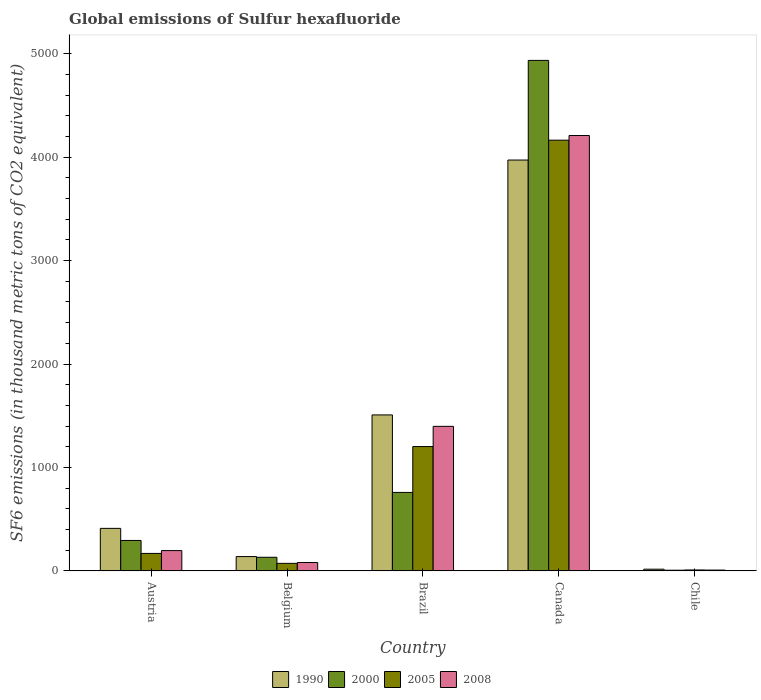How many different coloured bars are there?
Your answer should be very brief. 4. Are the number of bars per tick equal to the number of legend labels?
Offer a terse response. Yes. How many bars are there on the 5th tick from the left?
Ensure brevity in your answer.  4. How many bars are there on the 4th tick from the right?
Offer a very short reply. 4. What is the global emissions of Sulfur hexafluoride in 2008 in Canada?
Provide a short and direct response. 4208.8. Across all countries, what is the maximum global emissions of Sulfur hexafluoride in 2005?
Provide a short and direct response. 4163.8. Across all countries, what is the minimum global emissions of Sulfur hexafluoride in 2008?
Ensure brevity in your answer.  7.9. In which country was the global emissions of Sulfur hexafluoride in 2008 maximum?
Ensure brevity in your answer.  Canada. What is the total global emissions of Sulfur hexafluoride in 2005 in the graph?
Your answer should be compact. 5616.7. What is the difference between the global emissions of Sulfur hexafluoride in 2005 in Austria and that in Chile?
Keep it short and to the point. 160. What is the difference between the global emissions of Sulfur hexafluoride in 2000 in Austria and the global emissions of Sulfur hexafluoride in 1990 in Belgium?
Make the answer very short. 155.9. What is the average global emissions of Sulfur hexafluoride in 2000 per country?
Offer a terse response. 1225.32. What is the difference between the global emissions of Sulfur hexafluoride of/in 2008 and global emissions of Sulfur hexafluoride of/in 1990 in Austria?
Keep it short and to the point. -214.8. In how many countries, is the global emissions of Sulfur hexafluoride in 2008 greater than 2000 thousand metric tons?
Provide a short and direct response. 1. What is the ratio of the global emissions of Sulfur hexafluoride in 2005 in Brazil to that in Chile?
Give a very brief answer. 133.56. What is the difference between the highest and the second highest global emissions of Sulfur hexafluoride in 2008?
Provide a short and direct response. 4012.4. What is the difference between the highest and the lowest global emissions of Sulfur hexafluoride in 1990?
Offer a very short reply. 3955.3. Are all the bars in the graph horizontal?
Keep it short and to the point. No. What is the difference between two consecutive major ticks on the Y-axis?
Ensure brevity in your answer.  1000. Does the graph contain any zero values?
Your response must be concise. No. How are the legend labels stacked?
Your answer should be compact. Horizontal. What is the title of the graph?
Provide a succinct answer. Global emissions of Sulfur hexafluoride. What is the label or title of the X-axis?
Offer a very short reply. Country. What is the label or title of the Y-axis?
Make the answer very short. SF6 emissions (in thousand metric tons of CO2 equivalent). What is the SF6 emissions (in thousand metric tons of CO2 equivalent) in 1990 in Austria?
Provide a succinct answer. 411.2. What is the SF6 emissions (in thousand metric tons of CO2 equivalent) in 2000 in Austria?
Offer a terse response. 294.4. What is the SF6 emissions (in thousand metric tons of CO2 equivalent) of 2005 in Austria?
Ensure brevity in your answer.  169. What is the SF6 emissions (in thousand metric tons of CO2 equivalent) in 2008 in Austria?
Make the answer very short. 196.4. What is the SF6 emissions (in thousand metric tons of CO2 equivalent) in 1990 in Belgium?
Provide a succinct answer. 138.5. What is the SF6 emissions (in thousand metric tons of CO2 equivalent) of 2000 in Belgium?
Ensure brevity in your answer.  131.7. What is the SF6 emissions (in thousand metric tons of CO2 equivalent) of 2005 in Belgium?
Ensure brevity in your answer.  72.9. What is the SF6 emissions (in thousand metric tons of CO2 equivalent) of 2008 in Belgium?
Keep it short and to the point. 80.9. What is the SF6 emissions (in thousand metric tons of CO2 equivalent) of 1990 in Brazil?
Make the answer very short. 1507.9. What is the SF6 emissions (in thousand metric tons of CO2 equivalent) of 2000 in Brazil?
Give a very brief answer. 758.7. What is the SF6 emissions (in thousand metric tons of CO2 equivalent) of 2005 in Brazil?
Keep it short and to the point. 1202. What is the SF6 emissions (in thousand metric tons of CO2 equivalent) in 2008 in Brazil?
Your answer should be very brief. 1397.3. What is the SF6 emissions (in thousand metric tons of CO2 equivalent) of 1990 in Canada?
Provide a short and direct response. 3971.8. What is the SF6 emissions (in thousand metric tons of CO2 equivalent) in 2000 in Canada?
Give a very brief answer. 4935.1. What is the SF6 emissions (in thousand metric tons of CO2 equivalent) in 2005 in Canada?
Your response must be concise. 4163.8. What is the SF6 emissions (in thousand metric tons of CO2 equivalent) of 2008 in Canada?
Give a very brief answer. 4208.8. What is the SF6 emissions (in thousand metric tons of CO2 equivalent) of 1990 in Chile?
Provide a short and direct response. 16.5. Across all countries, what is the maximum SF6 emissions (in thousand metric tons of CO2 equivalent) in 1990?
Your answer should be very brief. 3971.8. Across all countries, what is the maximum SF6 emissions (in thousand metric tons of CO2 equivalent) of 2000?
Offer a terse response. 4935.1. Across all countries, what is the maximum SF6 emissions (in thousand metric tons of CO2 equivalent) in 2005?
Provide a short and direct response. 4163.8. Across all countries, what is the maximum SF6 emissions (in thousand metric tons of CO2 equivalent) in 2008?
Provide a short and direct response. 4208.8. Across all countries, what is the minimum SF6 emissions (in thousand metric tons of CO2 equivalent) of 2005?
Keep it short and to the point. 9. What is the total SF6 emissions (in thousand metric tons of CO2 equivalent) of 1990 in the graph?
Offer a terse response. 6045.9. What is the total SF6 emissions (in thousand metric tons of CO2 equivalent) in 2000 in the graph?
Offer a terse response. 6126.6. What is the total SF6 emissions (in thousand metric tons of CO2 equivalent) in 2005 in the graph?
Offer a very short reply. 5616.7. What is the total SF6 emissions (in thousand metric tons of CO2 equivalent) of 2008 in the graph?
Your response must be concise. 5891.3. What is the difference between the SF6 emissions (in thousand metric tons of CO2 equivalent) of 1990 in Austria and that in Belgium?
Provide a succinct answer. 272.7. What is the difference between the SF6 emissions (in thousand metric tons of CO2 equivalent) in 2000 in Austria and that in Belgium?
Provide a short and direct response. 162.7. What is the difference between the SF6 emissions (in thousand metric tons of CO2 equivalent) of 2005 in Austria and that in Belgium?
Your answer should be compact. 96.1. What is the difference between the SF6 emissions (in thousand metric tons of CO2 equivalent) in 2008 in Austria and that in Belgium?
Ensure brevity in your answer.  115.5. What is the difference between the SF6 emissions (in thousand metric tons of CO2 equivalent) of 1990 in Austria and that in Brazil?
Keep it short and to the point. -1096.7. What is the difference between the SF6 emissions (in thousand metric tons of CO2 equivalent) in 2000 in Austria and that in Brazil?
Offer a terse response. -464.3. What is the difference between the SF6 emissions (in thousand metric tons of CO2 equivalent) of 2005 in Austria and that in Brazil?
Make the answer very short. -1033. What is the difference between the SF6 emissions (in thousand metric tons of CO2 equivalent) in 2008 in Austria and that in Brazil?
Keep it short and to the point. -1200.9. What is the difference between the SF6 emissions (in thousand metric tons of CO2 equivalent) of 1990 in Austria and that in Canada?
Your answer should be compact. -3560.6. What is the difference between the SF6 emissions (in thousand metric tons of CO2 equivalent) in 2000 in Austria and that in Canada?
Your answer should be compact. -4640.7. What is the difference between the SF6 emissions (in thousand metric tons of CO2 equivalent) in 2005 in Austria and that in Canada?
Offer a terse response. -3994.8. What is the difference between the SF6 emissions (in thousand metric tons of CO2 equivalent) in 2008 in Austria and that in Canada?
Your answer should be compact. -4012.4. What is the difference between the SF6 emissions (in thousand metric tons of CO2 equivalent) of 1990 in Austria and that in Chile?
Give a very brief answer. 394.7. What is the difference between the SF6 emissions (in thousand metric tons of CO2 equivalent) in 2000 in Austria and that in Chile?
Make the answer very short. 287.7. What is the difference between the SF6 emissions (in thousand metric tons of CO2 equivalent) in 2005 in Austria and that in Chile?
Your answer should be very brief. 160. What is the difference between the SF6 emissions (in thousand metric tons of CO2 equivalent) in 2008 in Austria and that in Chile?
Your answer should be compact. 188.5. What is the difference between the SF6 emissions (in thousand metric tons of CO2 equivalent) in 1990 in Belgium and that in Brazil?
Your response must be concise. -1369.4. What is the difference between the SF6 emissions (in thousand metric tons of CO2 equivalent) of 2000 in Belgium and that in Brazil?
Keep it short and to the point. -627. What is the difference between the SF6 emissions (in thousand metric tons of CO2 equivalent) in 2005 in Belgium and that in Brazil?
Offer a very short reply. -1129.1. What is the difference between the SF6 emissions (in thousand metric tons of CO2 equivalent) of 2008 in Belgium and that in Brazil?
Provide a succinct answer. -1316.4. What is the difference between the SF6 emissions (in thousand metric tons of CO2 equivalent) of 1990 in Belgium and that in Canada?
Your answer should be compact. -3833.3. What is the difference between the SF6 emissions (in thousand metric tons of CO2 equivalent) of 2000 in Belgium and that in Canada?
Keep it short and to the point. -4803.4. What is the difference between the SF6 emissions (in thousand metric tons of CO2 equivalent) of 2005 in Belgium and that in Canada?
Provide a short and direct response. -4090.9. What is the difference between the SF6 emissions (in thousand metric tons of CO2 equivalent) in 2008 in Belgium and that in Canada?
Give a very brief answer. -4127.9. What is the difference between the SF6 emissions (in thousand metric tons of CO2 equivalent) of 1990 in Belgium and that in Chile?
Your response must be concise. 122. What is the difference between the SF6 emissions (in thousand metric tons of CO2 equivalent) in 2000 in Belgium and that in Chile?
Your response must be concise. 125. What is the difference between the SF6 emissions (in thousand metric tons of CO2 equivalent) in 2005 in Belgium and that in Chile?
Provide a short and direct response. 63.9. What is the difference between the SF6 emissions (in thousand metric tons of CO2 equivalent) in 2008 in Belgium and that in Chile?
Provide a succinct answer. 73. What is the difference between the SF6 emissions (in thousand metric tons of CO2 equivalent) of 1990 in Brazil and that in Canada?
Provide a succinct answer. -2463.9. What is the difference between the SF6 emissions (in thousand metric tons of CO2 equivalent) in 2000 in Brazil and that in Canada?
Offer a very short reply. -4176.4. What is the difference between the SF6 emissions (in thousand metric tons of CO2 equivalent) in 2005 in Brazil and that in Canada?
Provide a succinct answer. -2961.8. What is the difference between the SF6 emissions (in thousand metric tons of CO2 equivalent) in 2008 in Brazil and that in Canada?
Keep it short and to the point. -2811.5. What is the difference between the SF6 emissions (in thousand metric tons of CO2 equivalent) of 1990 in Brazil and that in Chile?
Your response must be concise. 1491.4. What is the difference between the SF6 emissions (in thousand metric tons of CO2 equivalent) of 2000 in Brazil and that in Chile?
Keep it short and to the point. 752. What is the difference between the SF6 emissions (in thousand metric tons of CO2 equivalent) of 2005 in Brazil and that in Chile?
Your response must be concise. 1193. What is the difference between the SF6 emissions (in thousand metric tons of CO2 equivalent) in 2008 in Brazil and that in Chile?
Provide a succinct answer. 1389.4. What is the difference between the SF6 emissions (in thousand metric tons of CO2 equivalent) of 1990 in Canada and that in Chile?
Keep it short and to the point. 3955.3. What is the difference between the SF6 emissions (in thousand metric tons of CO2 equivalent) of 2000 in Canada and that in Chile?
Your response must be concise. 4928.4. What is the difference between the SF6 emissions (in thousand metric tons of CO2 equivalent) in 2005 in Canada and that in Chile?
Give a very brief answer. 4154.8. What is the difference between the SF6 emissions (in thousand metric tons of CO2 equivalent) in 2008 in Canada and that in Chile?
Your answer should be very brief. 4200.9. What is the difference between the SF6 emissions (in thousand metric tons of CO2 equivalent) of 1990 in Austria and the SF6 emissions (in thousand metric tons of CO2 equivalent) of 2000 in Belgium?
Offer a terse response. 279.5. What is the difference between the SF6 emissions (in thousand metric tons of CO2 equivalent) of 1990 in Austria and the SF6 emissions (in thousand metric tons of CO2 equivalent) of 2005 in Belgium?
Offer a very short reply. 338.3. What is the difference between the SF6 emissions (in thousand metric tons of CO2 equivalent) of 1990 in Austria and the SF6 emissions (in thousand metric tons of CO2 equivalent) of 2008 in Belgium?
Offer a terse response. 330.3. What is the difference between the SF6 emissions (in thousand metric tons of CO2 equivalent) in 2000 in Austria and the SF6 emissions (in thousand metric tons of CO2 equivalent) in 2005 in Belgium?
Your answer should be compact. 221.5. What is the difference between the SF6 emissions (in thousand metric tons of CO2 equivalent) in 2000 in Austria and the SF6 emissions (in thousand metric tons of CO2 equivalent) in 2008 in Belgium?
Give a very brief answer. 213.5. What is the difference between the SF6 emissions (in thousand metric tons of CO2 equivalent) of 2005 in Austria and the SF6 emissions (in thousand metric tons of CO2 equivalent) of 2008 in Belgium?
Provide a short and direct response. 88.1. What is the difference between the SF6 emissions (in thousand metric tons of CO2 equivalent) in 1990 in Austria and the SF6 emissions (in thousand metric tons of CO2 equivalent) in 2000 in Brazil?
Provide a succinct answer. -347.5. What is the difference between the SF6 emissions (in thousand metric tons of CO2 equivalent) of 1990 in Austria and the SF6 emissions (in thousand metric tons of CO2 equivalent) of 2005 in Brazil?
Your answer should be very brief. -790.8. What is the difference between the SF6 emissions (in thousand metric tons of CO2 equivalent) of 1990 in Austria and the SF6 emissions (in thousand metric tons of CO2 equivalent) of 2008 in Brazil?
Ensure brevity in your answer.  -986.1. What is the difference between the SF6 emissions (in thousand metric tons of CO2 equivalent) of 2000 in Austria and the SF6 emissions (in thousand metric tons of CO2 equivalent) of 2005 in Brazil?
Provide a short and direct response. -907.6. What is the difference between the SF6 emissions (in thousand metric tons of CO2 equivalent) of 2000 in Austria and the SF6 emissions (in thousand metric tons of CO2 equivalent) of 2008 in Brazil?
Keep it short and to the point. -1102.9. What is the difference between the SF6 emissions (in thousand metric tons of CO2 equivalent) in 2005 in Austria and the SF6 emissions (in thousand metric tons of CO2 equivalent) in 2008 in Brazil?
Your response must be concise. -1228.3. What is the difference between the SF6 emissions (in thousand metric tons of CO2 equivalent) in 1990 in Austria and the SF6 emissions (in thousand metric tons of CO2 equivalent) in 2000 in Canada?
Your answer should be compact. -4523.9. What is the difference between the SF6 emissions (in thousand metric tons of CO2 equivalent) of 1990 in Austria and the SF6 emissions (in thousand metric tons of CO2 equivalent) of 2005 in Canada?
Ensure brevity in your answer.  -3752.6. What is the difference between the SF6 emissions (in thousand metric tons of CO2 equivalent) in 1990 in Austria and the SF6 emissions (in thousand metric tons of CO2 equivalent) in 2008 in Canada?
Your answer should be very brief. -3797.6. What is the difference between the SF6 emissions (in thousand metric tons of CO2 equivalent) in 2000 in Austria and the SF6 emissions (in thousand metric tons of CO2 equivalent) in 2005 in Canada?
Your answer should be very brief. -3869.4. What is the difference between the SF6 emissions (in thousand metric tons of CO2 equivalent) in 2000 in Austria and the SF6 emissions (in thousand metric tons of CO2 equivalent) in 2008 in Canada?
Provide a succinct answer. -3914.4. What is the difference between the SF6 emissions (in thousand metric tons of CO2 equivalent) of 2005 in Austria and the SF6 emissions (in thousand metric tons of CO2 equivalent) of 2008 in Canada?
Your response must be concise. -4039.8. What is the difference between the SF6 emissions (in thousand metric tons of CO2 equivalent) of 1990 in Austria and the SF6 emissions (in thousand metric tons of CO2 equivalent) of 2000 in Chile?
Your answer should be compact. 404.5. What is the difference between the SF6 emissions (in thousand metric tons of CO2 equivalent) in 1990 in Austria and the SF6 emissions (in thousand metric tons of CO2 equivalent) in 2005 in Chile?
Keep it short and to the point. 402.2. What is the difference between the SF6 emissions (in thousand metric tons of CO2 equivalent) of 1990 in Austria and the SF6 emissions (in thousand metric tons of CO2 equivalent) of 2008 in Chile?
Ensure brevity in your answer.  403.3. What is the difference between the SF6 emissions (in thousand metric tons of CO2 equivalent) of 2000 in Austria and the SF6 emissions (in thousand metric tons of CO2 equivalent) of 2005 in Chile?
Make the answer very short. 285.4. What is the difference between the SF6 emissions (in thousand metric tons of CO2 equivalent) in 2000 in Austria and the SF6 emissions (in thousand metric tons of CO2 equivalent) in 2008 in Chile?
Give a very brief answer. 286.5. What is the difference between the SF6 emissions (in thousand metric tons of CO2 equivalent) of 2005 in Austria and the SF6 emissions (in thousand metric tons of CO2 equivalent) of 2008 in Chile?
Ensure brevity in your answer.  161.1. What is the difference between the SF6 emissions (in thousand metric tons of CO2 equivalent) of 1990 in Belgium and the SF6 emissions (in thousand metric tons of CO2 equivalent) of 2000 in Brazil?
Make the answer very short. -620.2. What is the difference between the SF6 emissions (in thousand metric tons of CO2 equivalent) of 1990 in Belgium and the SF6 emissions (in thousand metric tons of CO2 equivalent) of 2005 in Brazil?
Offer a terse response. -1063.5. What is the difference between the SF6 emissions (in thousand metric tons of CO2 equivalent) of 1990 in Belgium and the SF6 emissions (in thousand metric tons of CO2 equivalent) of 2008 in Brazil?
Ensure brevity in your answer.  -1258.8. What is the difference between the SF6 emissions (in thousand metric tons of CO2 equivalent) of 2000 in Belgium and the SF6 emissions (in thousand metric tons of CO2 equivalent) of 2005 in Brazil?
Your answer should be compact. -1070.3. What is the difference between the SF6 emissions (in thousand metric tons of CO2 equivalent) of 2000 in Belgium and the SF6 emissions (in thousand metric tons of CO2 equivalent) of 2008 in Brazil?
Provide a short and direct response. -1265.6. What is the difference between the SF6 emissions (in thousand metric tons of CO2 equivalent) in 2005 in Belgium and the SF6 emissions (in thousand metric tons of CO2 equivalent) in 2008 in Brazil?
Give a very brief answer. -1324.4. What is the difference between the SF6 emissions (in thousand metric tons of CO2 equivalent) in 1990 in Belgium and the SF6 emissions (in thousand metric tons of CO2 equivalent) in 2000 in Canada?
Keep it short and to the point. -4796.6. What is the difference between the SF6 emissions (in thousand metric tons of CO2 equivalent) of 1990 in Belgium and the SF6 emissions (in thousand metric tons of CO2 equivalent) of 2005 in Canada?
Offer a very short reply. -4025.3. What is the difference between the SF6 emissions (in thousand metric tons of CO2 equivalent) in 1990 in Belgium and the SF6 emissions (in thousand metric tons of CO2 equivalent) in 2008 in Canada?
Ensure brevity in your answer.  -4070.3. What is the difference between the SF6 emissions (in thousand metric tons of CO2 equivalent) of 2000 in Belgium and the SF6 emissions (in thousand metric tons of CO2 equivalent) of 2005 in Canada?
Your answer should be compact. -4032.1. What is the difference between the SF6 emissions (in thousand metric tons of CO2 equivalent) in 2000 in Belgium and the SF6 emissions (in thousand metric tons of CO2 equivalent) in 2008 in Canada?
Your answer should be very brief. -4077.1. What is the difference between the SF6 emissions (in thousand metric tons of CO2 equivalent) in 2005 in Belgium and the SF6 emissions (in thousand metric tons of CO2 equivalent) in 2008 in Canada?
Offer a terse response. -4135.9. What is the difference between the SF6 emissions (in thousand metric tons of CO2 equivalent) of 1990 in Belgium and the SF6 emissions (in thousand metric tons of CO2 equivalent) of 2000 in Chile?
Give a very brief answer. 131.8. What is the difference between the SF6 emissions (in thousand metric tons of CO2 equivalent) in 1990 in Belgium and the SF6 emissions (in thousand metric tons of CO2 equivalent) in 2005 in Chile?
Keep it short and to the point. 129.5. What is the difference between the SF6 emissions (in thousand metric tons of CO2 equivalent) of 1990 in Belgium and the SF6 emissions (in thousand metric tons of CO2 equivalent) of 2008 in Chile?
Offer a terse response. 130.6. What is the difference between the SF6 emissions (in thousand metric tons of CO2 equivalent) of 2000 in Belgium and the SF6 emissions (in thousand metric tons of CO2 equivalent) of 2005 in Chile?
Provide a short and direct response. 122.7. What is the difference between the SF6 emissions (in thousand metric tons of CO2 equivalent) of 2000 in Belgium and the SF6 emissions (in thousand metric tons of CO2 equivalent) of 2008 in Chile?
Provide a short and direct response. 123.8. What is the difference between the SF6 emissions (in thousand metric tons of CO2 equivalent) of 2005 in Belgium and the SF6 emissions (in thousand metric tons of CO2 equivalent) of 2008 in Chile?
Make the answer very short. 65. What is the difference between the SF6 emissions (in thousand metric tons of CO2 equivalent) of 1990 in Brazil and the SF6 emissions (in thousand metric tons of CO2 equivalent) of 2000 in Canada?
Make the answer very short. -3427.2. What is the difference between the SF6 emissions (in thousand metric tons of CO2 equivalent) of 1990 in Brazil and the SF6 emissions (in thousand metric tons of CO2 equivalent) of 2005 in Canada?
Offer a very short reply. -2655.9. What is the difference between the SF6 emissions (in thousand metric tons of CO2 equivalent) of 1990 in Brazil and the SF6 emissions (in thousand metric tons of CO2 equivalent) of 2008 in Canada?
Provide a short and direct response. -2700.9. What is the difference between the SF6 emissions (in thousand metric tons of CO2 equivalent) of 2000 in Brazil and the SF6 emissions (in thousand metric tons of CO2 equivalent) of 2005 in Canada?
Provide a short and direct response. -3405.1. What is the difference between the SF6 emissions (in thousand metric tons of CO2 equivalent) of 2000 in Brazil and the SF6 emissions (in thousand metric tons of CO2 equivalent) of 2008 in Canada?
Keep it short and to the point. -3450.1. What is the difference between the SF6 emissions (in thousand metric tons of CO2 equivalent) in 2005 in Brazil and the SF6 emissions (in thousand metric tons of CO2 equivalent) in 2008 in Canada?
Provide a short and direct response. -3006.8. What is the difference between the SF6 emissions (in thousand metric tons of CO2 equivalent) of 1990 in Brazil and the SF6 emissions (in thousand metric tons of CO2 equivalent) of 2000 in Chile?
Provide a short and direct response. 1501.2. What is the difference between the SF6 emissions (in thousand metric tons of CO2 equivalent) of 1990 in Brazil and the SF6 emissions (in thousand metric tons of CO2 equivalent) of 2005 in Chile?
Make the answer very short. 1498.9. What is the difference between the SF6 emissions (in thousand metric tons of CO2 equivalent) in 1990 in Brazil and the SF6 emissions (in thousand metric tons of CO2 equivalent) in 2008 in Chile?
Your answer should be compact. 1500. What is the difference between the SF6 emissions (in thousand metric tons of CO2 equivalent) of 2000 in Brazil and the SF6 emissions (in thousand metric tons of CO2 equivalent) of 2005 in Chile?
Make the answer very short. 749.7. What is the difference between the SF6 emissions (in thousand metric tons of CO2 equivalent) in 2000 in Brazil and the SF6 emissions (in thousand metric tons of CO2 equivalent) in 2008 in Chile?
Keep it short and to the point. 750.8. What is the difference between the SF6 emissions (in thousand metric tons of CO2 equivalent) of 2005 in Brazil and the SF6 emissions (in thousand metric tons of CO2 equivalent) of 2008 in Chile?
Your response must be concise. 1194.1. What is the difference between the SF6 emissions (in thousand metric tons of CO2 equivalent) of 1990 in Canada and the SF6 emissions (in thousand metric tons of CO2 equivalent) of 2000 in Chile?
Your answer should be very brief. 3965.1. What is the difference between the SF6 emissions (in thousand metric tons of CO2 equivalent) in 1990 in Canada and the SF6 emissions (in thousand metric tons of CO2 equivalent) in 2005 in Chile?
Make the answer very short. 3962.8. What is the difference between the SF6 emissions (in thousand metric tons of CO2 equivalent) in 1990 in Canada and the SF6 emissions (in thousand metric tons of CO2 equivalent) in 2008 in Chile?
Your answer should be very brief. 3963.9. What is the difference between the SF6 emissions (in thousand metric tons of CO2 equivalent) in 2000 in Canada and the SF6 emissions (in thousand metric tons of CO2 equivalent) in 2005 in Chile?
Provide a short and direct response. 4926.1. What is the difference between the SF6 emissions (in thousand metric tons of CO2 equivalent) of 2000 in Canada and the SF6 emissions (in thousand metric tons of CO2 equivalent) of 2008 in Chile?
Provide a short and direct response. 4927.2. What is the difference between the SF6 emissions (in thousand metric tons of CO2 equivalent) in 2005 in Canada and the SF6 emissions (in thousand metric tons of CO2 equivalent) in 2008 in Chile?
Your response must be concise. 4155.9. What is the average SF6 emissions (in thousand metric tons of CO2 equivalent) in 1990 per country?
Give a very brief answer. 1209.18. What is the average SF6 emissions (in thousand metric tons of CO2 equivalent) in 2000 per country?
Offer a very short reply. 1225.32. What is the average SF6 emissions (in thousand metric tons of CO2 equivalent) in 2005 per country?
Offer a terse response. 1123.34. What is the average SF6 emissions (in thousand metric tons of CO2 equivalent) of 2008 per country?
Keep it short and to the point. 1178.26. What is the difference between the SF6 emissions (in thousand metric tons of CO2 equivalent) in 1990 and SF6 emissions (in thousand metric tons of CO2 equivalent) in 2000 in Austria?
Keep it short and to the point. 116.8. What is the difference between the SF6 emissions (in thousand metric tons of CO2 equivalent) in 1990 and SF6 emissions (in thousand metric tons of CO2 equivalent) in 2005 in Austria?
Your answer should be very brief. 242.2. What is the difference between the SF6 emissions (in thousand metric tons of CO2 equivalent) of 1990 and SF6 emissions (in thousand metric tons of CO2 equivalent) of 2008 in Austria?
Your response must be concise. 214.8. What is the difference between the SF6 emissions (in thousand metric tons of CO2 equivalent) in 2000 and SF6 emissions (in thousand metric tons of CO2 equivalent) in 2005 in Austria?
Your answer should be very brief. 125.4. What is the difference between the SF6 emissions (in thousand metric tons of CO2 equivalent) of 2005 and SF6 emissions (in thousand metric tons of CO2 equivalent) of 2008 in Austria?
Give a very brief answer. -27.4. What is the difference between the SF6 emissions (in thousand metric tons of CO2 equivalent) of 1990 and SF6 emissions (in thousand metric tons of CO2 equivalent) of 2005 in Belgium?
Provide a short and direct response. 65.6. What is the difference between the SF6 emissions (in thousand metric tons of CO2 equivalent) in 1990 and SF6 emissions (in thousand metric tons of CO2 equivalent) in 2008 in Belgium?
Provide a short and direct response. 57.6. What is the difference between the SF6 emissions (in thousand metric tons of CO2 equivalent) in 2000 and SF6 emissions (in thousand metric tons of CO2 equivalent) in 2005 in Belgium?
Your response must be concise. 58.8. What is the difference between the SF6 emissions (in thousand metric tons of CO2 equivalent) of 2000 and SF6 emissions (in thousand metric tons of CO2 equivalent) of 2008 in Belgium?
Keep it short and to the point. 50.8. What is the difference between the SF6 emissions (in thousand metric tons of CO2 equivalent) of 1990 and SF6 emissions (in thousand metric tons of CO2 equivalent) of 2000 in Brazil?
Your answer should be very brief. 749.2. What is the difference between the SF6 emissions (in thousand metric tons of CO2 equivalent) of 1990 and SF6 emissions (in thousand metric tons of CO2 equivalent) of 2005 in Brazil?
Give a very brief answer. 305.9. What is the difference between the SF6 emissions (in thousand metric tons of CO2 equivalent) in 1990 and SF6 emissions (in thousand metric tons of CO2 equivalent) in 2008 in Brazil?
Provide a short and direct response. 110.6. What is the difference between the SF6 emissions (in thousand metric tons of CO2 equivalent) in 2000 and SF6 emissions (in thousand metric tons of CO2 equivalent) in 2005 in Brazil?
Make the answer very short. -443.3. What is the difference between the SF6 emissions (in thousand metric tons of CO2 equivalent) of 2000 and SF6 emissions (in thousand metric tons of CO2 equivalent) of 2008 in Brazil?
Keep it short and to the point. -638.6. What is the difference between the SF6 emissions (in thousand metric tons of CO2 equivalent) in 2005 and SF6 emissions (in thousand metric tons of CO2 equivalent) in 2008 in Brazil?
Your response must be concise. -195.3. What is the difference between the SF6 emissions (in thousand metric tons of CO2 equivalent) in 1990 and SF6 emissions (in thousand metric tons of CO2 equivalent) in 2000 in Canada?
Your answer should be very brief. -963.3. What is the difference between the SF6 emissions (in thousand metric tons of CO2 equivalent) in 1990 and SF6 emissions (in thousand metric tons of CO2 equivalent) in 2005 in Canada?
Provide a succinct answer. -192. What is the difference between the SF6 emissions (in thousand metric tons of CO2 equivalent) in 1990 and SF6 emissions (in thousand metric tons of CO2 equivalent) in 2008 in Canada?
Your response must be concise. -237. What is the difference between the SF6 emissions (in thousand metric tons of CO2 equivalent) in 2000 and SF6 emissions (in thousand metric tons of CO2 equivalent) in 2005 in Canada?
Give a very brief answer. 771.3. What is the difference between the SF6 emissions (in thousand metric tons of CO2 equivalent) of 2000 and SF6 emissions (in thousand metric tons of CO2 equivalent) of 2008 in Canada?
Keep it short and to the point. 726.3. What is the difference between the SF6 emissions (in thousand metric tons of CO2 equivalent) in 2005 and SF6 emissions (in thousand metric tons of CO2 equivalent) in 2008 in Canada?
Offer a terse response. -45. What is the difference between the SF6 emissions (in thousand metric tons of CO2 equivalent) in 1990 and SF6 emissions (in thousand metric tons of CO2 equivalent) in 2000 in Chile?
Give a very brief answer. 9.8. What is the difference between the SF6 emissions (in thousand metric tons of CO2 equivalent) of 1990 and SF6 emissions (in thousand metric tons of CO2 equivalent) of 2005 in Chile?
Give a very brief answer. 7.5. What is the difference between the SF6 emissions (in thousand metric tons of CO2 equivalent) of 1990 and SF6 emissions (in thousand metric tons of CO2 equivalent) of 2008 in Chile?
Offer a very short reply. 8.6. What is the ratio of the SF6 emissions (in thousand metric tons of CO2 equivalent) of 1990 in Austria to that in Belgium?
Offer a terse response. 2.97. What is the ratio of the SF6 emissions (in thousand metric tons of CO2 equivalent) of 2000 in Austria to that in Belgium?
Your answer should be compact. 2.24. What is the ratio of the SF6 emissions (in thousand metric tons of CO2 equivalent) of 2005 in Austria to that in Belgium?
Keep it short and to the point. 2.32. What is the ratio of the SF6 emissions (in thousand metric tons of CO2 equivalent) in 2008 in Austria to that in Belgium?
Your answer should be compact. 2.43. What is the ratio of the SF6 emissions (in thousand metric tons of CO2 equivalent) in 1990 in Austria to that in Brazil?
Give a very brief answer. 0.27. What is the ratio of the SF6 emissions (in thousand metric tons of CO2 equivalent) in 2000 in Austria to that in Brazil?
Provide a succinct answer. 0.39. What is the ratio of the SF6 emissions (in thousand metric tons of CO2 equivalent) of 2005 in Austria to that in Brazil?
Provide a succinct answer. 0.14. What is the ratio of the SF6 emissions (in thousand metric tons of CO2 equivalent) of 2008 in Austria to that in Brazil?
Give a very brief answer. 0.14. What is the ratio of the SF6 emissions (in thousand metric tons of CO2 equivalent) in 1990 in Austria to that in Canada?
Ensure brevity in your answer.  0.1. What is the ratio of the SF6 emissions (in thousand metric tons of CO2 equivalent) in 2000 in Austria to that in Canada?
Your answer should be compact. 0.06. What is the ratio of the SF6 emissions (in thousand metric tons of CO2 equivalent) of 2005 in Austria to that in Canada?
Your answer should be very brief. 0.04. What is the ratio of the SF6 emissions (in thousand metric tons of CO2 equivalent) in 2008 in Austria to that in Canada?
Your response must be concise. 0.05. What is the ratio of the SF6 emissions (in thousand metric tons of CO2 equivalent) in 1990 in Austria to that in Chile?
Your answer should be compact. 24.92. What is the ratio of the SF6 emissions (in thousand metric tons of CO2 equivalent) in 2000 in Austria to that in Chile?
Provide a succinct answer. 43.94. What is the ratio of the SF6 emissions (in thousand metric tons of CO2 equivalent) of 2005 in Austria to that in Chile?
Your answer should be compact. 18.78. What is the ratio of the SF6 emissions (in thousand metric tons of CO2 equivalent) in 2008 in Austria to that in Chile?
Ensure brevity in your answer.  24.86. What is the ratio of the SF6 emissions (in thousand metric tons of CO2 equivalent) of 1990 in Belgium to that in Brazil?
Provide a succinct answer. 0.09. What is the ratio of the SF6 emissions (in thousand metric tons of CO2 equivalent) of 2000 in Belgium to that in Brazil?
Provide a short and direct response. 0.17. What is the ratio of the SF6 emissions (in thousand metric tons of CO2 equivalent) of 2005 in Belgium to that in Brazil?
Provide a succinct answer. 0.06. What is the ratio of the SF6 emissions (in thousand metric tons of CO2 equivalent) of 2008 in Belgium to that in Brazil?
Your response must be concise. 0.06. What is the ratio of the SF6 emissions (in thousand metric tons of CO2 equivalent) of 1990 in Belgium to that in Canada?
Ensure brevity in your answer.  0.03. What is the ratio of the SF6 emissions (in thousand metric tons of CO2 equivalent) in 2000 in Belgium to that in Canada?
Your answer should be very brief. 0.03. What is the ratio of the SF6 emissions (in thousand metric tons of CO2 equivalent) of 2005 in Belgium to that in Canada?
Make the answer very short. 0.02. What is the ratio of the SF6 emissions (in thousand metric tons of CO2 equivalent) in 2008 in Belgium to that in Canada?
Your response must be concise. 0.02. What is the ratio of the SF6 emissions (in thousand metric tons of CO2 equivalent) of 1990 in Belgium to that in Chile?
Provide a succinct answer. 8.39. What is the ratio of the SF6 emissions (in thousand metric tons of CO2 equivalent) in 2000 in Belgium to that in Chile?
Provide a short and direct response. 19.66. What is the ratio of the SF6 emissions (in thousand metric tons of CO2 equivalent) of 2008 in Belgium to that in Chile?
Offer a terse response. 10.24. What is the ratio of the SF6 emissions (in thousand metric tons of CO2 equivalent) in 1990 in Brazil to that in Canada?
Offer a very short reply. 0.38. What is the ratio of the SF6 emissions (in thousand metric tons of CO2 equivalent) of 2000 in Brazil to that in Canada?
Your answer should be very brief. 0.15. What is the ratio of the SF6 emissions (in thousand metric tons of CO2 equivalent) in 2005 in Brazil to that in Canada?
Ensure brevity in your answer.  0.29. What is the ratio of the SF6 emissions (in thousand metric tons of CO2 equivalent) in 2008 in Brazil to that in Canada?
Your answer should be compact. 0.33. What is the ratio of the SF6 emissions (in thousand metric tons of CO2 equivalent) in 1990 in Brazil to that in Chile?
Provide a short and direct response. 91.39. What is the ratio of the SF6 emissions (in thousand metric tons of CO2 equivalent) of 2000 in Brazil to that in Chile?
Give a very brief answer. 113.24. What is the ratio of the SF6 emissions (in thousand metric tons of CO2 equivalent) of 2005 in Brazil to that in Chile?
Offer a very short reply. 133.56. What is the ratio of the SF6 emissions (in thousand metric tons of CO2 equivalent) of 2008 in Brazil to that in Chile?
Ensure brevity in your answer.  176.87. What is the ratio of the SF6 emissions (in thousand metric tons of CO2 equivalent) in 1990 in Canada to that in Chile?
Offer a terse response. 240.72. What is the ratio of the SF6 emissions (in thousand metric tons of CO2 equivalent) in 2000 in Canada to that in Chile?
Offer a very short reply. 736.58. What is the ratio of the SF6 emissions (in thousand metric tons of CO2 equivalent) in 2005 in Canada to that in Chile?
Offer a very short reply. 462.64. What is the ratio of the SF6 emissions (in thousand metric tons of CO2 equivalent) of 2008 in Canada to that in Chile?
Ensure brevity in your answer.  532.76. What is the difference between the highest and the second highest SF6 emissions (in thousand metric tons of CO2 equivalent) in 1990?
Your response must be concise. 2463.9. What is the difference between the highest and the second highest SF6 emissions (in thousand metric tons of CO2 equivalent) in 2000?
Give a very brief answer. 4176.4. What is the difference between the highest and the second highest SF6 emissions (in thousand metric tons of CO2 equivalent) of 2005?
Provide a short and direct response. 2961.8. What is the difference between the highest and the second highest SF6 emissions (in thousand metric tons of CO2 equivalent) of 2008?
Provide a succinct answer. 2811.5. What is the difference between the highest and the lowest SF6 emissions (in thousand metric tons of CO2 equivalent) in 1990?
Give a very brief answer. 3955.3. What is the difference between the highest and the lowest SF6 emissions (in thousand metric tons of CO2 equivalent) of 2000?
Make the answer very short. 4928.4. What is the difference between the highest and the lowest SF6 emissions (in thousand metric tons of CO2 equivalent) of 2005?
Your answer should be very brief. 4154.8. What is the difference between the highest and the lowest SF6 emissions (in thousand metric tons of CO2 equivalent) in 2008?
Your answer should be compact. 4200.9. 